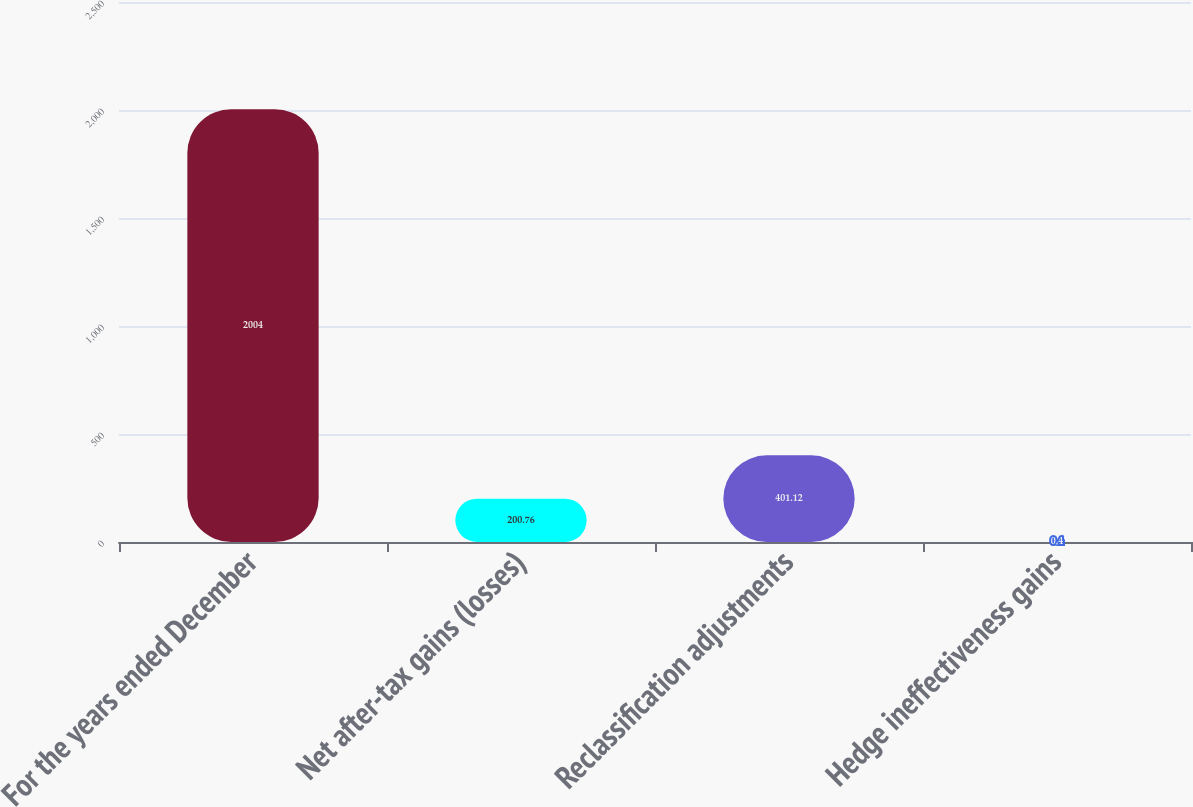Convert chart. <chart><loc_0><loc_0><loc_500><loc_500><bar_chart><fcel>For the years ended December<fcel>Net after-tax gains (losses)<fcel>Reclassification adjustments<fcel>Hedge ineffectiveness gains<nl><fcel>2004<fcel>200.76<fcel>401.12<fcel>0.4<nl></chart> 